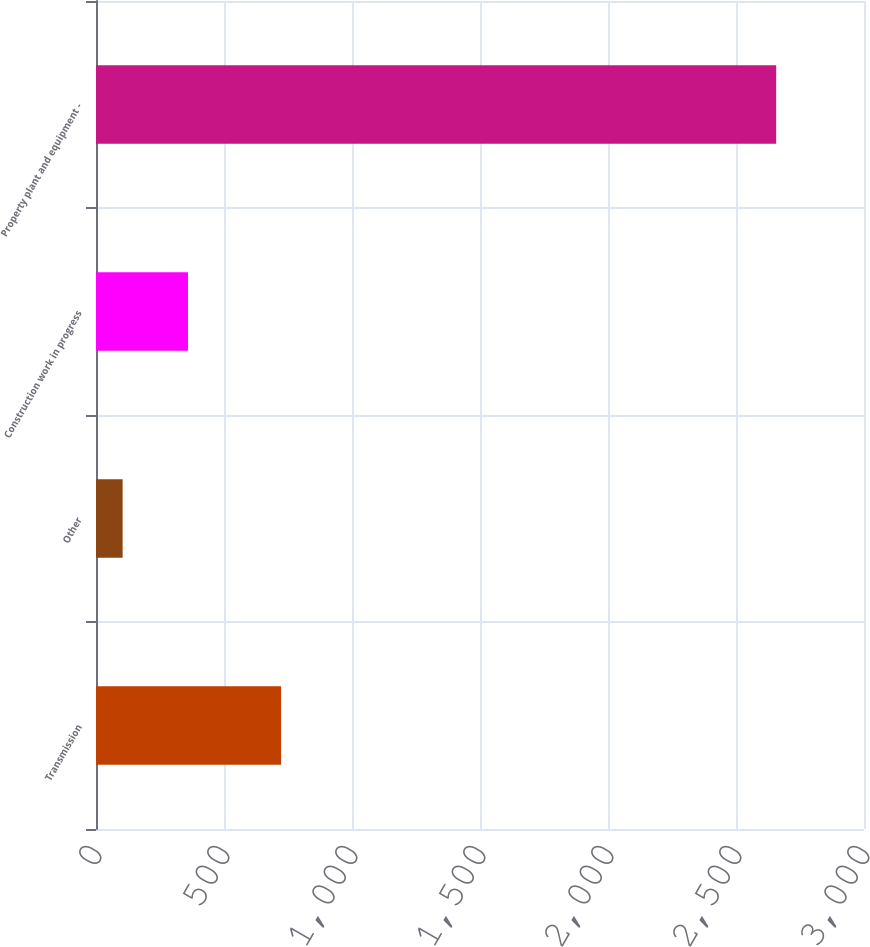<chart> <loc_0><loc_0><loc_500><loc_500><bar_chart><fcel>Transmission<fcel>Other<fcel>Construction work in progress<fcel>Property plant and equipment -<nl><fcel>723<fcel>104<fcel>359.3<fcel>2657<nl></chart> 